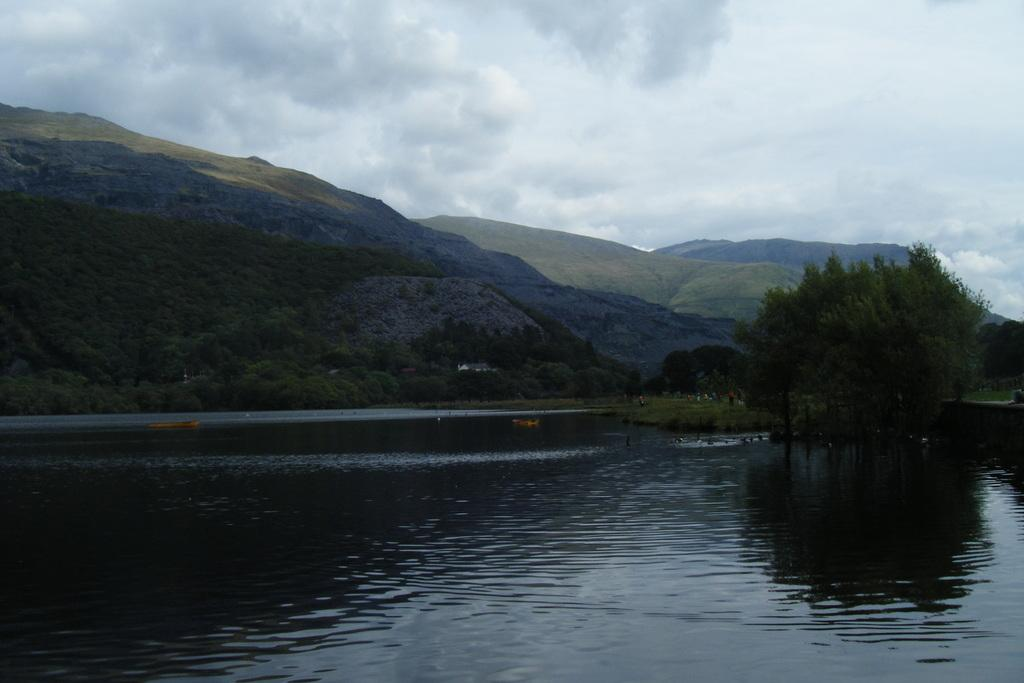What type of body of water is present in the image? There is a lake in the image. What can be seen in the distance behind the lake? There are trees and mountains in the background of the image. What is the condition of the sky in the image? The sky is cloudy in the background of the image. Can you see any bats flying over the lake in the image? There are no bats visible in the image; it only features a lake, trees, mountains, and a cloudy sky. Are there any berries growing on the trees in the image? There is no mention of berries or any specific type of vegetation on the trees in the image. 